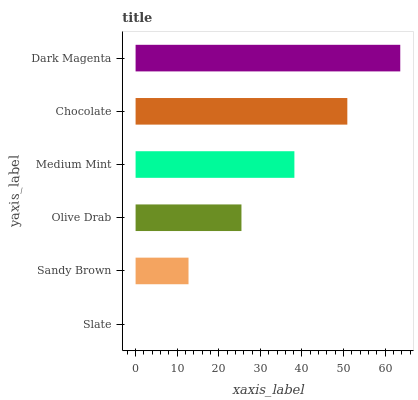Is Slate the minimum?
Answer yes or no. Yes. Is Dark Magenta the maximum?
Answer yes or no. Yes. Is Sandy Brown the minimum?
Answer yes or no. No. Is Sandy Brown the maximum?
Answer yes or no. No. Is Sandy Brown greater than Slate?
Answer yes or no. Yes. Is Slate less than Sandy Brown?
Answer yes or no. Yes. Is Slate greater than Sandy Brown?
Answer yes or no. No. Is Sandy Brown less than Slate?
Answer yes or no. No. Is Medium Mint the high median?
Answer yes or no. Yes. Is Olive Drab the low median?
Answer yes or no. Yes. Is Dark Magenta the high median?
Answer yes or no. No. Is Medium Mint the low median?
Answer yes or no. No. 